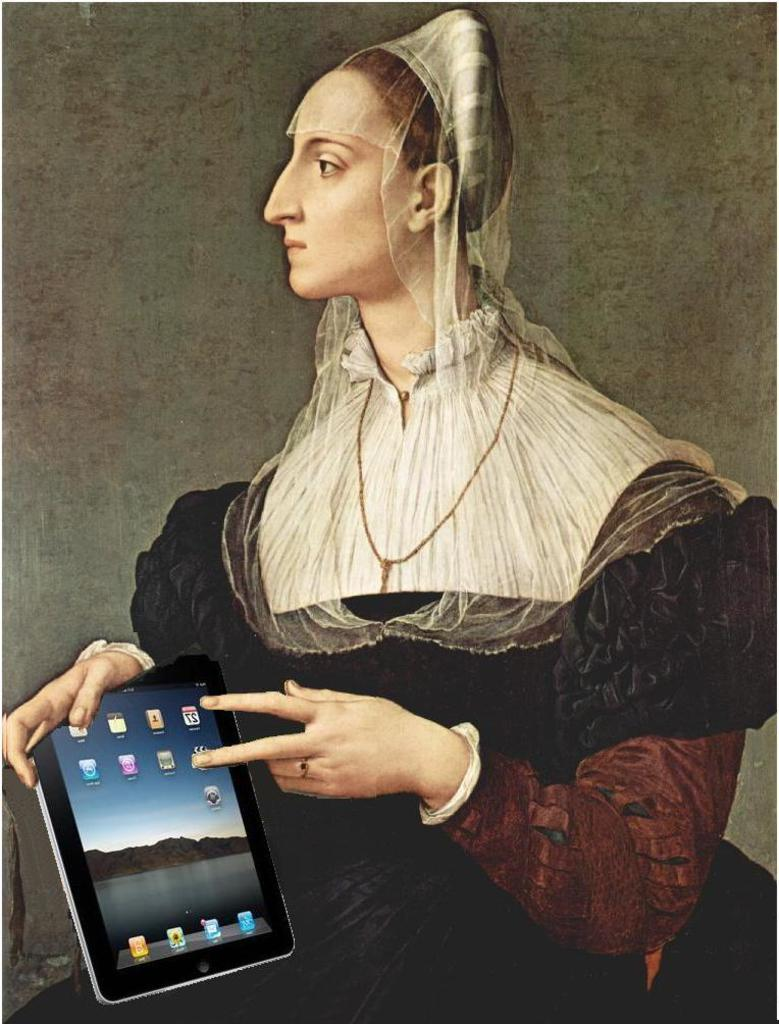Who is the main subject in the image? There is a lady in the image. What is the lady holding in the image? The lady is holding an iPad. Where is the lady and the iPad located in the image? The lady and the iPad are in the center of the image. What type of religious veil is the lady wearing in the image? There is no veil present in the image, and the lady's religion is not mentioned or depicted. 